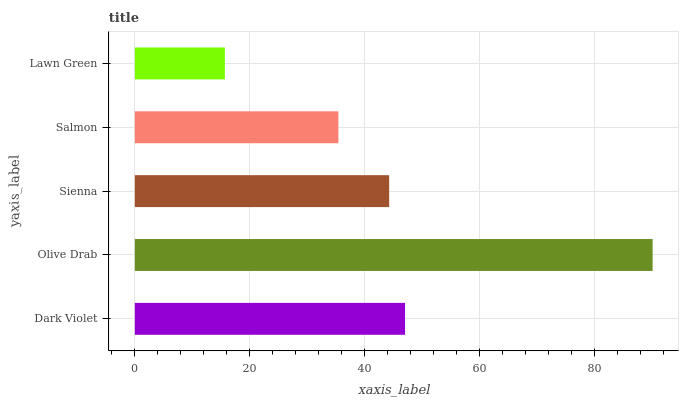Is Lawn Green the minimum?
Answer yes or no. Yes. Is Olive Drab the maximum?
Answer yes or no. Yes. Is Sienna the minimum?
Answer yes or no. No. Is Sienna the maximum?
Answer yes or no. No. Is Olive Drab greater than Sienna?
Answer yes or no. Yes. Is Sienna less than Olive Drab?
Answer yes or no. Yes. Is Sienna greater than Olive Drab?
Answer yes or no. No. Is Olive Drab less than Sienna?
Answer yes or no. No. Is Sienna the high median?
Answer yes or no. Yes. Is Sienna the low median?
Answer yes or no. Yes. Is Dark Violet the high median?
Answer yes or no. No. Is Salmon the low median?
Answer yes or no. No. 